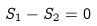<formula> <loc_0><loc_0><loc_500><loc_500>S _ { 1 } - S _ { 2 } = 0</formula> 